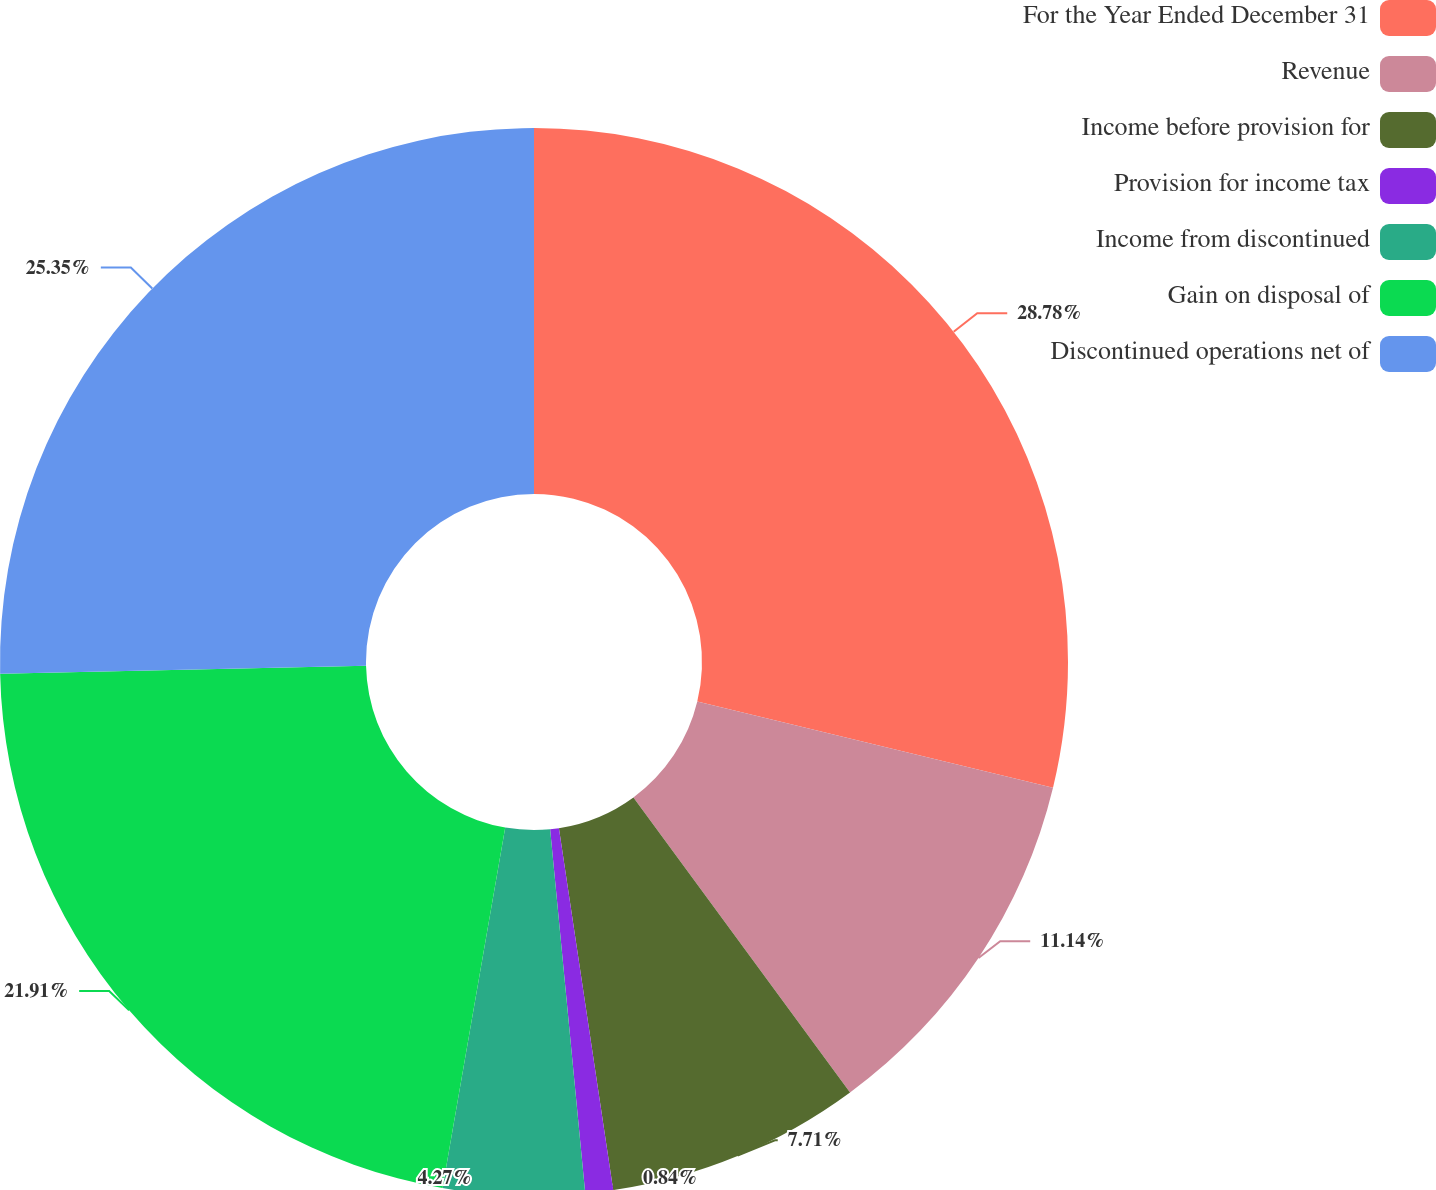Convert chart. <chart><loc_0><loc_0><loc_500><loc_500><pie_chart><fcel>For the Year Ended December 31<fcel>Revenue<fcel>Income before provision for<fcel>Provision for income tax<fcel>Income from discontinued<fcel>Gain on disposal of<fcel>Discontinued operations net of<nl><fcel>28.78%<fcel>11.14%<fcel>7.71%<fcel>0.84%<fcel>4.27%<fcel>21.91%<fcel>25.35%<nl></chart> 